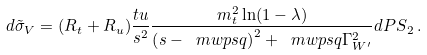Convert formula to latex. <formula><loc_0><loc_0><loc_500><loc_500>d \tilde { \sigma } _ { V } = ( R _ { t } + R _ { u } ) \frac { t u } { s ^ { 2 } } \frac { m _ { t } ^ { 2 } \ln ( 1 - \lambda ) } { \left ( s - \ m w p s q \right ) ^ { 2 } + \ m w p s q \Gamma _ { W ^ { \prime } } ^ { 2 } } d { P S } _ { 2 } \, .</formula> 